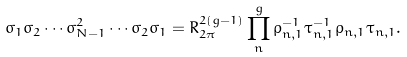Convert formula to latex. <formula><loc_0><loc_0><loc_500><loc_500>\sigma _ { 1 } \sigma _ { 2 } \cdots \sigma ^ { 2 } _ { N - 1 } \cdots \sigma _ { 2 } \sigma _ { 1 } = R ^ { 2 ( g - 1 ) } _ { 2 \pi } \prod ^ { g } _ { n } \rho ^ { - 1 } _ { n , 1 } \tau ^ { - 1 } _ { n , 1 } \rho _ { n , 1 } \tau _ { n , 1 } .</formula> 